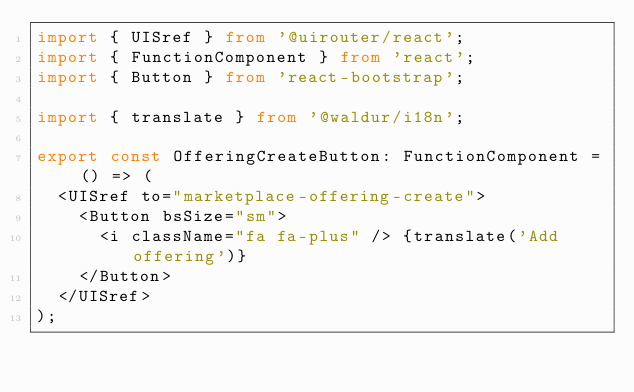Convert code to text. <code><loc_0><loc_0><loc_500><loc_500><_TypeScript_>import { UISref } from '@uirouter/react';
import { FunctionComponent } from 'react';
import { Button } from 'react-bootstrap';

import { translate } from '@waldur/i18n';

export const OfferingCreateButton: FunctionComponent = () => (
  <UISref to="marketplace-offering-create">
    <Button bsSize="sm">
      <i className="fa fa-plus" /> {translate('Add offering')}
    </Button>
  </UISref>
);
</code> 